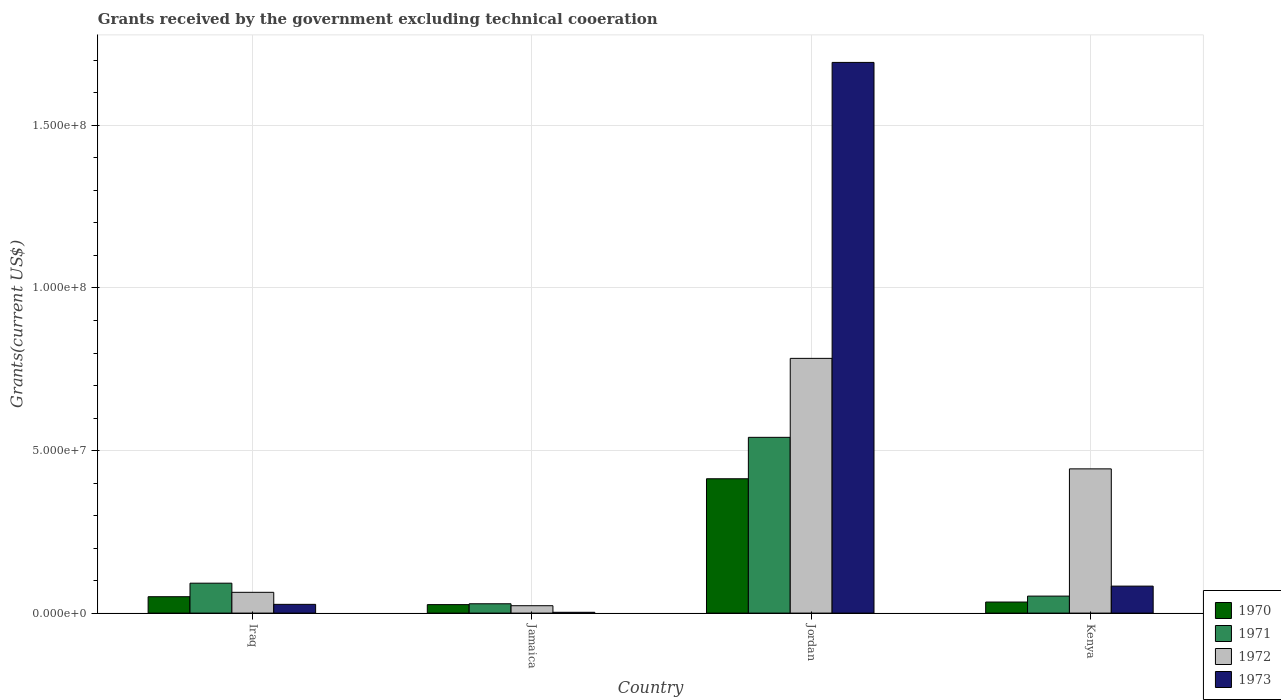How many different coloured bars are there?
Ensure brevity in your answer.  4. Are the number of bars per tick equal to the number of legend labels?
Give a very brief answer. Yes. Are the number of bars on each tick of the X-axis equal?
Provide a short and direct response. Yes. How many bars are there on the 3rd tick from the left?
Make the answer very short. 4. What is the label of the 3rd group of bars from the left?
Offer a terse response. Jordan. What is the total grants received by the government in 1973 in Iraq?
Give a very brief answer. 2.69e+06. Across all countries, what is the maximum total grants received by the government in 1971?
Give a very brief answer. 5.41e+07. In which country was the total grants received by the government in 1971 maximum?
Your answer should be compact. Jordan. In which country was the total grants received by the government in 1973 minimum?
Offer a very short reply. Jamaica. What is the total total grants received by the government in 1971 in the graph?
Make the answer very short. 7.14e+07. What is the difference between the total grants received by the government in 1970 in Iraq and that in Jordan?
Offer a terse response. -3.63e+07. What is the difference between the total grants received by the government in 1970 in Jamaica and the total grants received by the government in 1971 in Jordan?
Make the answer very short. -5.14e+07. What is the average total grants received by the government in 1971 per country?
Keep it short and to the point. 1.78e+07. What is the difference between the total grants received by the government of/in 1970 and total grants received by the government of/in 1971 in Jamaica?
Provide a succinct answer. -2.60e+05. In how many countries, is the total grants received by the government in 1971 greater than 110000000 US$?
Make the answer very short. 0. What is the ratio of the total grants received by the government in 1972 in Iraq to that in Kenya?
Make the answer very short. 0.14. What is the difference between the highest and the second highest total grants received by the government in 1973?
Offer a terse response. 1.61e+08. What is the difference between the highest and the lowest total grants received by the government in 1973?
Provide a short and direct response. 1.69e+08. Is it the case that in every country, the sum of the total grants received by the government in 1970 and total grants received by the government in 1973 is greater than the sum of total grants received by the government in 1971 and total grants received by the government in 1972?
Make the answer very short. No. What does the 3rd bar from the left in Jordan represents?
Provide a succinct answer. 1972. What does the 1st bar from the right in Kenya represents?
Give a very brief answer. 1973. How many countries are there in the graph?
Your response must be concise. 4. Are the values on the major ticks of Y-axis written in scientific E-notation?
Ensure brevity in your answer.  Yes. Does the graph contain grids?
Provide a short and direct response. Yes. What is the title of the graph?
Provide a succinct answer. Grants received by the government excluding technical cooeration. What is the label or title of the X-axis?
Offer a very short reply. Country. What is the label or title of the Y-axis?
Your answer should be compact. Grants(current US$). What is the Grants(current US$) of 1970 in Iraq?
Give a very brief answer. 5.04e+06. What is the Grants(current US$) in 1971 in Iraq?
Provide a short and direct response. 9.20e+06. What is the Grants(current US$) in 1972 in Iraq?
Your answer should be very brief. 6.39e+06. What is the Grants(current US$) in 1973 in Iraq?
Your answer should be very brief. 2.69e+06. What is the Grants(current US$) of 1970 in Jamaica?
Keep it short and to the point. 2.61e+06. What is the Grants(current US$) of 1971 in Jamaica?
Make the answer very short. 2.87e+06. What is the Grants(current US$) of 1972 in Jamaica?
Provide a short and direct response. 2.27e+06. What is the Grants(current US$) of 1973 in Jamaica?
Provide a succinct answer. 2.50e+05. What is the Grants(current US$) of 1970 in Jordan?
Ensure brevity in your answer.  4.13e+07. What is the Grants(current US$) in 1971 in Jordan?
Provide a short and direct response. 5.41e+07. What is the Grants(current US$) in 1972 in Jordan?
Provide a succinct answer. 7.84e+07. What is the Grants(current US$) in 1973 in Jordan?
Make the answer very short. 1.69e+08. What is the Grants(current US$) of 1970 in Kenya?
Offer a very short reply. 3.40e+06. What is the Grants(current US$) in 1971 in Kenya?
Provide a succinct answer. 5.23e+06. What is the Grants(current US$) of 1972 in Kenya?
Provide a succinct answer. 4.44e+07. What is the Grants(current US$) of 1973 in Kenya?
Your answer should be very brief. 8.30e+06. Across all countries, what is the maximum Grants(current US$) of 1970?
Provide a short and direct response. 4.13e+07. Across all countries, what is the maximum Grants(current US$) of 1971?
Your response must be concise. 5.41e+07. Across all countries, what is the maximum Grants(current US$) in 1972?
Your answer should be compact. 7.84e+07. Across all countries, what is the maximum Grants(current US$) in 1973?
Your answer should be compact. 1.69e+08. Across all countries, what is the minimum Grants(current US$) in 1970?
Your answer should be very brief. 2.61e+06. Across all countries, what is the minimum Grants(current US$) in 1971?
Give a very brief answer. 2.87e+06. Across all countries, what is the minimum Grants(current US$) of 1972?
Offer a terse response. 2.27e+06. Across all countries, what is the minimum Grants(current US$) in 1973?
Offer a very short reply. 2.50e+05. What is the total Grants(current US$) in 1970 in the graph?
Your answer should be compact. 5.24e+07. What is the total Grants(current US$) in 1971 in the graph?
Provide a succinct answer. 7.14e+07. What is the total Grants(current US$) in 1972 in the graph?
Provide a short and direct response. 1.31e+08. What is the total Grants(current US$) in 1973 in the graph?
Your answer should be very brief. 1.81e+08. What is the difference between the Grants(current US$) of 1970 in Iraq and that in Jamaica?
Your response must be concise. 2.43e+06. What is the difference between the Grants(current US$) of 1971 in Iraq and that in Jamaica?
Ensure brevity in your answer.  6.33e+06. What is the difference between the Grants(current US$) of 1972 in Iraq and that in Jamaica?
Provide a short and direct response. 4.12e+06. What is the difference between the Grants(current US$) of 1973 in Iraq and that in Jamaica?
Your response must be concise. 2.44e+06. What is the difference between the Grants(current US$) of 1970 in Iraq and that in Jordan?
Offer a very short reply. -3.63e+07. What is the difference between the Grants(current US$) in 1971 in Iraq and that in Jordan?
Give a very brief answer. -4.49e+07. What is the difference between the Grants(current US$) of 1972 in Iraq and that in Jordan?
Offer a terse response. -7.20e+07. What is the difference between the Grants(current US$) of 1973 in Iraq and that in Jordan?
Make the answer very short. -1.67e+08. What is the difference between the Grants(current US$) in 1970 in Iraq and that in Kenya?
Keep it short and to the point. 1.64e+06. What is the difference between the Grants(current US$) in 1971 in Iraq and that in Kenya?
Make the answer very short. 3.97e+06. What is the difference between the Grants(current US$) in 1972 in Iraq and that in Kenya?
Offer a very short reply. -3.80e+07. What is the difference between the Grants(current US$) in 1973 in Iraq and that in Kenya?
Give a very brief answer. -5.61e+06. What is the difference between the Grants(current US$) in 1970 in Jamaica and that in Jordan?
Your answer should be very brief. -3.87e+07. What is the difference between the Grants(current US$) in 1971 in Jamaica and that in Jordan?
Provide a short and direct response. -5.12e+07. What is the difference between the Grants(current US$) of 1972 in Jamaica and that in Jordan?
Make the answer very short. -7.61e+07. What is the difference between the Grants(current US$) of 1973 in Jamaica and that in Jordan?
Keep it short and to the point. -1.69e+08. What is the difference between the Grants(current US$) in 1970 in Jamaica and that in Kenya?
Ensure brevity in your answer.  -7.90e+05. What is the difference between the Grants(current US$) of 1971 in Jamaica and that in Kenya?
Provide a succinct answer. -2.36e+06. What is the difference between the Grants(current US$) in 1972 in Jamaica and that in Kenya?
Offer a terse response. -4.21e+07. What is the difference between the Grants(current US$) in 1973 in Jamaica and that in Kenya?
Offer a very short reply. -8.05e+06. What is the difference between the Grants(current US$) of 1970 in Jordan and that in Kenya?
Offer a very short reply. 3.79e+07. What is the difference between the Grants(current US$) of 1971 in Jordan and that in Kenya?
Your response must be concise. 4.88e+07. What is the difference between the Grants(current US$) in 1972 in Jordan and that in Kenya?
Your answer should be very brief. 3.40e+07. What is the difference between the Grants(current US$) of 1973 in Jordan and that in Kenya?
Ensure brevity in your answer.  1.61e+08. What is the difference between the Grants(current US$) in 1970 in Iraq and the Grants(current US$) in 1971 in Jamaica?
Provide a succinct answer. 2.17e+06. What is the difference between the Grants(current US$) of 1970 in Iraq and the Grants(current US$) of 1972 in Jamaica?
Your answer should be very brief. 2.77e+06. What is the difference between the Grants(current US$) of 1970 in Iraq and the Grants(current US$) of 1973 in Jamaica?
Your response must be concise. 4.79e+06. What is the difference between the Grants(current US$) of 1971 in Iraq and the Grants(current US$) of 1972 in Jamaica?
Provide a succinct answer. 6.93e+06. What is the difference between the Grants(current US$) in 1971 in Iraq and the Grants(current US$) in 1973 in Jamaica?
Provide a succinct answer. 8.95e+06. What is the difference between the Grants(current US$) of 1972 in Iraq and the Grants(current US$) of 1973 in Jamaica?
Your answer should be compact. 6.14e+06. What is the difference between the Grants(current US$) of 1970 in Iraq and the Grants(current US$) of 1971 in Jordan?
Offer a terse response. -4.90e+07. What is the difference between the Grants(current US$) in 1970 in Iraq and the Grants(current US$) in 1972 in Jordan?
Offer a very short reply. -7.33e+07. What is the difference between the Grants(current US$) in 1970 in Iraq and the Grants(current US$) in 1973 in Jordan?
Your answer should be compact. -1.64e+08. What is the difference between the Grants(current US$) in 1971 in Iraq and the Grants(current US$) in 1972 in Jordan?
Provide a short and direct response. -6.92e+07. What is the difference between the Grants(current US$) in 1971 in Iraq and the Grants(current US$) in 1973 in Jordan?
Provide a succinct answer. -1.60e+08. What is the difference between the Grants(current US$) of 1972 in Iraq and the Grants(current US$) of 1973 in Jordan?
Make the answer very short. -1.63e+08. What is the difference between the Grants(current US$) in 1970 in Iraq and the Grants(current US$) in 1972 in Kenya?
Ensure brevity in your answer.  -3.93e+07. What is the difference between the Grants(current US$) in 1970 in Iraq and the Grants(current US$) in 1973 in Kenya?
Your answer should be compact. -3.26e+06. What is the difference between the Grants(current US$) of 1971 in Iraq and the Grants(current US$) of 1972 in Kenya?
Your answer should be very brief. -3.52e+07. What is the difference between the Grants(current US$) in 1972 in Iraq and the Grants(current US$) in 1973 in Kenya?
Your answer should be compact. -1.91e+06. What is the difference between the Grants(current US$) of 1970 in Jamaica and the Grants(current US$) of 1971 in Jordan?
Keep it short and to the point. -5.14e+07. What is the difference between the Grants(current US$) in 1970 in Jamaica and the Grants(current US$) in 1972 in Jordan?
Your answer should be compact. -7.57e+07. What is the difference between the Grants(current US$) of 1970 in Jamaica and the Grants(current US$) of 1973 in Jordan?
Give a very brief answer. -1.67e+08. What is the difference between the Grants(current US$) in 1971 in Jamaica and the Grants(current US$) in 1972 in Jordan?
Provide a succinct answer. -7.55e+07. What is the difference between the Grants(current US$) in 1971 in Jamaica and the Grants(current US$) in 1973 in Jordan?
Ensure brevity in your answer.  -1.67e+08. What is the difference between the Grants(current US$) of 1972 in Jamaica and the Grants(current US$) of 1973 in Jordan?
Your answer should be very brief. -1.67e+08. What is the difference between the Grants(current US$) of 1970 in Jamaica and the Grants(current US$) of 1971 in Kenya?
Your answer should be compact. -2.62e+06. What is the difference between the Grants(current US$) in 1970 in Jamaica and the Grants(current US$) in 1972 in Kenya?
Your answer should be compact. -4.18e+07. What is the difference between the Grants(current US$) in 1970 in Jamaica and the Grants(current US$) in 1973 in Kenya?
Your answer should be very brief. -5.69e+06. What is the difference between the Grants(current US$) in 1971 in Jamaica and the Grants(current US$) in 1972 in Kenya?
Offer a very short reply. -4.15e+07. What is the difference between the Grants(current US$) of 1971 in Jamaica and the Grants(current US$) of 1973 in Kenya?
Provide a succinct answer. -5.43e+06. What is the difference between the Grants(current US$) in 1972 in Jamaica and the Grants(current US$) in 1973 in Kenya?
Provide a short and direct response. -6.03e+06. What is the difference between the Grants(current US$) of 1970 in Jordan and the Grants(current US$) of 1971 in Kenya?
Provide a succinct answer. 3.61e+07. What is the difference between the Grants(current US$) of 1970 in Jordan and the Grants(current US$) of 1972 in Kenya?
Offer a terse response. -3.04e+06. What is the difference between the Grants(current US$) of 1970 in Jordan and the Grants(current US$) of 1973 in Kenya?
Give a very brief answer. 3.30e+07. What is the difference between the Grants(current US$) in 1971 in Jordan and the Grants(current US$) in 1972 in Kenya?
Offer a terse response. 9.70e+06. What is the difference between the Grants(current US$) in 1971 in Jordan and the Grants(current US$) in 1973 in Kenya?
Your response must be concise. 4.58e+07. What is the difference between the Grants(current US$) in 1972 in Jordan and the Grants(current US$) in 1973 in Kenya?
Ensure brevity in your answer.  7.00e+07. What is the average Grants(current US$) of 1970 per country?
Your answer should be very brief. 1.31e+07. What is the average Grants(current US$) in 1971 per country?
Keep it short and to the point. 1.78e+07. What is the average Grants(current US$) in 1972 per country?
Offer a terse response. 3.28e+07. What is the average Grants(current US$) in 1973 per country?
Keep it short and to the point. 4.52e+07. What is the difference between the Grants(current US$) of 1970 and Grants(current US$) of 1971 in Iraq?
Provide a succinct answer. -4.16e+06. What is the difference between the Grants(current US$) of 1970 and Grants(current US$) of 1972 in Iraq?
Ensure brevity in your answer.  -1.35e+06. What is the difference between the Grants(current US$) of 1970 and Grants(current US$) of 1973 in Iraq?
Provide a succinct answer. 2.35e+06. What is the difference between the Grants(current US$) of 1971 and Grants(current US$) of 1972 in Iraq?
Your answer should be very brief. 2.81e+06. What is the difference between the Grants(current US$) in 1971 and Grants(current US$) in 1973 in Iraq?
Your answer should be very brief. 6.51e+06. What is the difference between the Grants(current US$) in 1972 and Grants(current US$) in 1973 in Iraq?
Provide a succinct answer. 3.70e+06. What is the difference between the Grants(current US$) of 1970 and Grants(current US$) of 1972 in Jamaica?
Your answer should be very brief. 3.40e+05. What is the difference between the Grants(current US$) of 1970 and Grants(current US$) of 1973 in Jamaica?
Ensure brevity in your answer.  2.36e+06. What is the difference between the Grants(current US$) in 1971 and Grants(current US$) in 1973 in Jamaica?
Offer a terse response. 2.62e+06. What is the difference between the Grants(current US$) of 1972 and Grants(current US$) of 1973 in Jamaica?
Give a very brief answer. 2.02e+06. What is the difference between the Grants(current US$) of 1970 and Grants(current US$) of 1971 in Jordan?
Keep it short and to the point. -1.27e+07. What is the difference between the Grants(current US$) in 1970 and Grants(current US$) in 1972 in Jordan?
Your answer should be very brief. -3.70e+07. What is the difference between the Grants(current US$) in 1970 and Grants(current US$) in 1973 in Jordan?
Your answer should be very brief. -1.28e+08. What is the difference between the Grants(current US$) of 1971 and Grants(current US$) of 1972 in Jordan?
Your answer should be very brief. -2.43e+07. What is the difference between the Grants(current US$) in 1971 and Grants(current US$) in 1973 in Jordan?
Your answer should be compact. -1.15e+08. What is the difference between the Grants(current US$) in 1972 and Grants(current US$) in 1973 in Jordan?
Make the answer very short. -9.10e+07. What is the difference between the Grants(current US$) in 1970 and Grants(current US$) in 1971 in Kenya?
Offer a terse response. -1.83e+06. What is the difference between the Grants(current US$) of 1970 and Grants(current US$) of 1972 in Kenya?
Give a very brief answer. -4.10e+07. What is the difference between the Grants(current US$) in 1970 and Grants(current US$) in 1973 in Kenya?
Offer a terse response. -4.90e+06. What is the difference between the Grants(current US$) in 1971 and Grants(current US$) in 1972 in Kenya?
Provide a short and direct response. -3.91e+07. What is the difference between the Grants(current US$) in 1971 and Grants(current US$) in 1973 in Kenya?
Your answer should be very brief. -3.07e+06. What is the difference between the Grants(current US$) of 1972 and Grants(current US$) of 1973 in Kenya?
Provide a succinct answer. 3.61e+07. What is the ratio of the Grants(current US$) in 1970 in Iraq to that in Jamaica?
Provide a short and direct response. 1.93. What is the ratio of the Grants(current US$) of 1971 in Iraq to that in Jamaica?
Your answer should be compact. 3.21. What is the ratio of the Grants(current US$) in 1972 in Iraq to that in Jamaica?
Make the answer very short. 2.81. What is the ratio of the Grants(current US$) of 1973 in Iraq to that in Jamaica?
Make the answer very short. 10.76. What is the ratio of the Grants(current US$) of 1970 in Iraq to that in Jordan?
Provide a short and direct response. 0.12. What is the ratio of the Grants(current US$) of 1971 in Iraq to that in Jordan?
Your answer should be compact. 0.17. What is the ratio of the Grants(current US$) of 1972 in Iraq to that in Jordan?
Offer a terse response. 0.08. What is the ratio of the Grants(current US$) in 1973 in Iraq to that in Jordan?
Provide a short and direct response. 0.02. What is the ratio of the Grants(current US$) in 1970 in Iraq to that in Kenya?
Make the answer very short. 1.48. What is the ratio of the Grants(current US$) in 1971 in Iraq to that in Kenya?
Make the answer very short. 1.76. What is the ratio of the Grants(current US$) of 1972 in Iraq to that in Kenya?
Ensure brevity in your answer.  0.14. What is the ratio of the Grants(current US$) in 1973 in Iraq to that in Kenya?
Provide a short and direct response. 0.32. What is the ratio of the Grants(current US$) in 1970 in Jamaica to that in Jordan?
Your answer should be compact. 0.06. What is the ratio of the Grants(current US$) of 1971 in Jamaica to that in Jordan?
Provide a succinct answer. 0.05. What is the ratio of the Grants(current US$) in 1972 in Jamaica to that in Jordan?
Make the answer very short. 0.03. What is the ratio of the Grants(current US$) of 1973 in Jamaica to that in Jordan?
Provide a succinct answer. 0. What is the ratio of the Grants(current US$) in 1970 in Jamaica to that in Kenya?
Make the answer very short. 0.77. What is the ratio of the Grants(current US$) in 1971 in Jamaica to that in Kenya?
Your answer should be very brief. 0.55. What is the ratio of the Grants(current US$) in 1972 in Jamaica to that in Kenya?
Your answer should be compact. 0.05. What is the ratio of the Grants(current US$) of 1973 in Jamaica to that in Kenya?
Provide a succinct answer. 0.03. What is the ratio of the Grants(current US$) of 1970 in Jordan to that in Kenya?
Offer a very short reply. 12.15. What is the ratio of the Grants(current US$) of 1971 in Jordan to that in Kenya?
Offer a terse response. 10.34. What is the ratio of the Grants(current US$) in 1972 in Jordan to that in Kenya?
Make the answer very short. 1.77. What is the ratio of the Grants(current US$) of 1973 in Jordan to that in Kenya?
Provide a succinct answer. 20.41. What is the difference between the highest and the second highest Grants(current US$) of 1970?
Offer a very short reply. 3.63e+07. What is the difference between the highest and the second highest Grants(current US$) in 1971?
Your response must be concise. 4.49e+07. What is the difference between the highest and the second highest Grants(current US$) in 1972?
Make the answer very short. 3.40e+07. What is the difference between the highest and the second highest Grants(current US$) in 1973?
Offer a very short reply. 1.61e+08. What is the difference between the highest and the lowest Grants(current US$) in 1970?
Make the answer very short. 3.87e+07. What is the difference between the highest and the lowest Grants(current US$) in 1971?
Make the answer very short. 5.12e+07. What is the difference between the highest and the lowest Grants(current US$) of 1972?
Keep it short and to the point. 7.61e+07. What is the difference between the highest and the lowest Grants(current US$) of 1973?
Offer a terse response. 1.69e+08. 